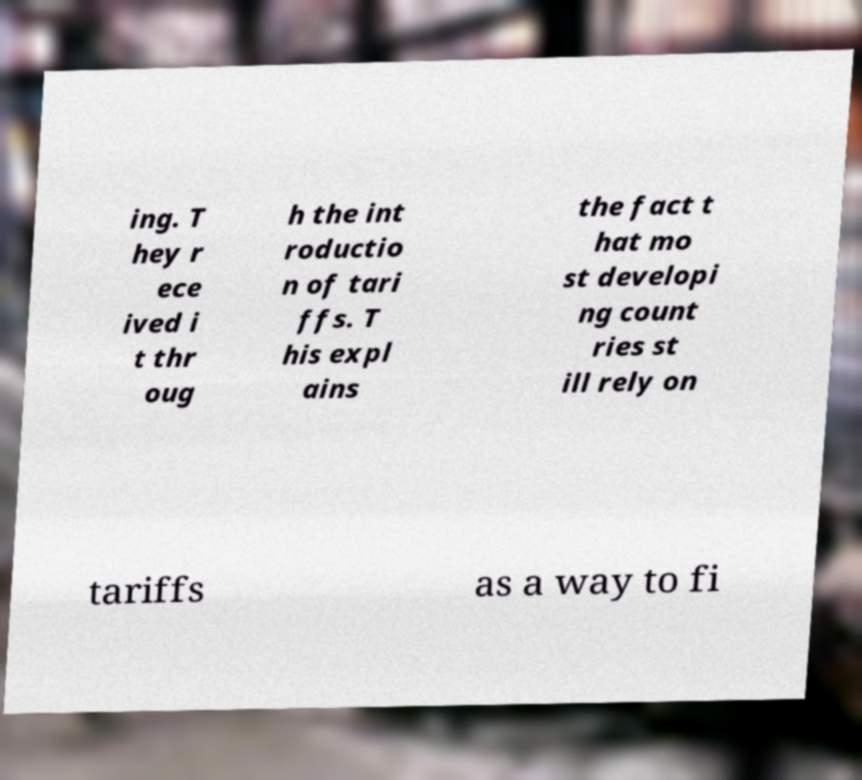Can you read and provide the text displayed in the image?This photo seems to have some interesting text. Can you extract and type it out for me? ing. T hey r ece ived i t thr oug h the int roductio n of tari ffs. T his expl ains the fact t hat mo st developi ng count ries st ill rely on tariffs as a way to fi 